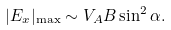Convert formula to latex. <formula><loc_0><loc_0><loc_500><loc_500>| E _ { x } | _ { \max } \sim V _ { A } B \sin ^ { 2 } \alpha .</formula> 